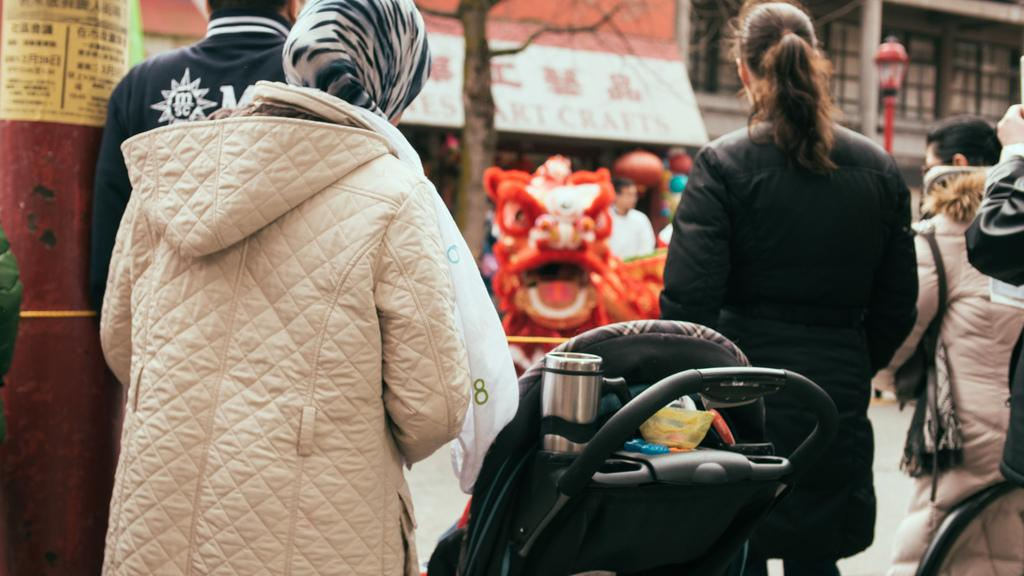How many women are in the image? There are two women in the image. What are the women wearing? The women are wearing jackets. What is located in the middle of the image? There is a trolley in the middle of the image. What can be seen in the background of the image? There are houses and a tree in the background of the image. What is at the bottom of the image? There is a road at the bottom of the image. What type of can is visible on the trolley in the image? There is no can visible on the trolley in the image. How many vans are parked on the road in the image? There are no vans present in the image; only a road is visible at the bottom. 